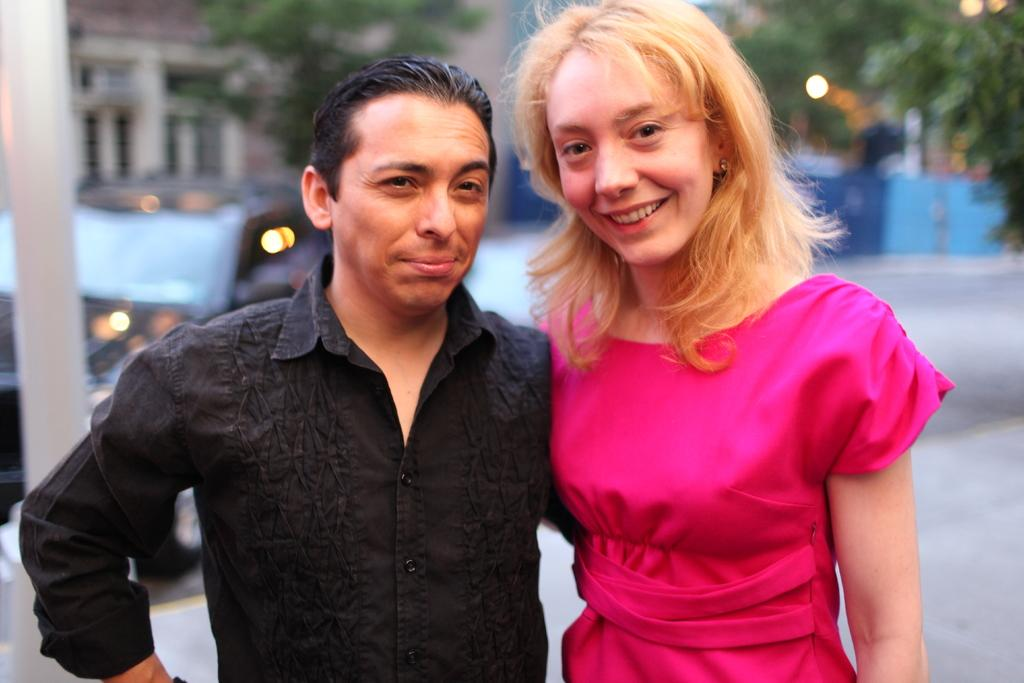How many people are in the image? There are two people standing in the image. What expressions do the people have? The people are smiling. Can you describe the background of the image? The background is blurry, and there is a pole, trees, a car, and a building visible. What color is the toe of the person on the left in the image? There is no visible toe in the image, as both people are standing upright. 